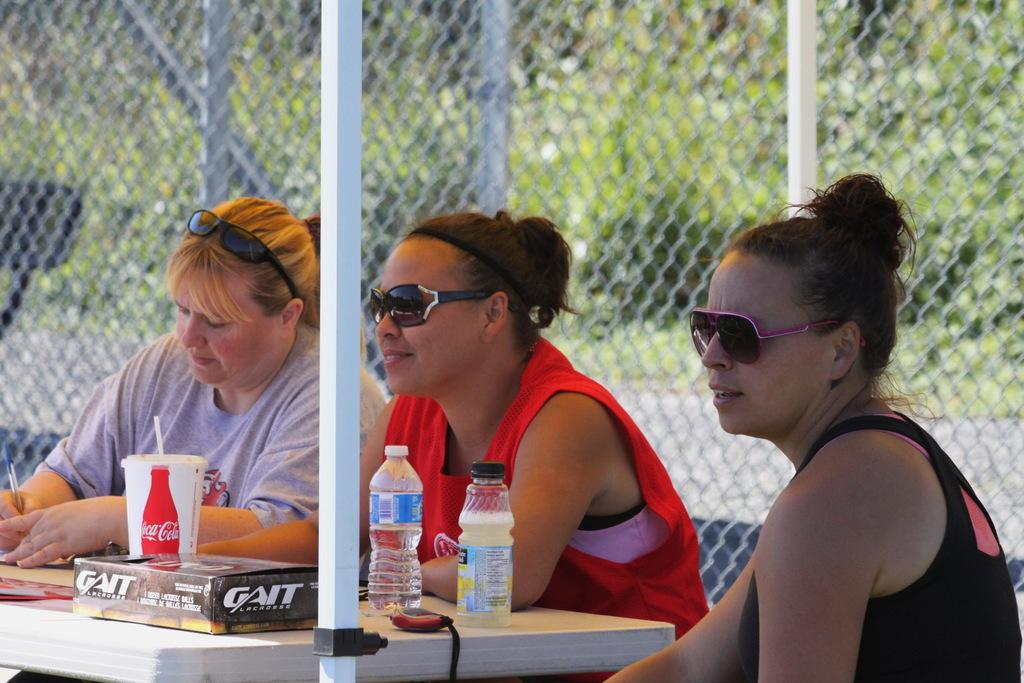What piece of furniture is present in the image? There is a table in the image. What can be seen on the table? There are bottles on the table, including a Coke bottle. What else is on the table besides bottles? There are other items on the table. How many women are sitting around the table? There are three women sitting around the table. What is visible in the background of the image? There is a mesh visible in the background. What type of rice is being served on the table in the image? There is no rice present in the image; it features a table with bottles and other items, as well as three women sitting around it. What flavor of jam is on the table in the image? There is no jam present in the image. 